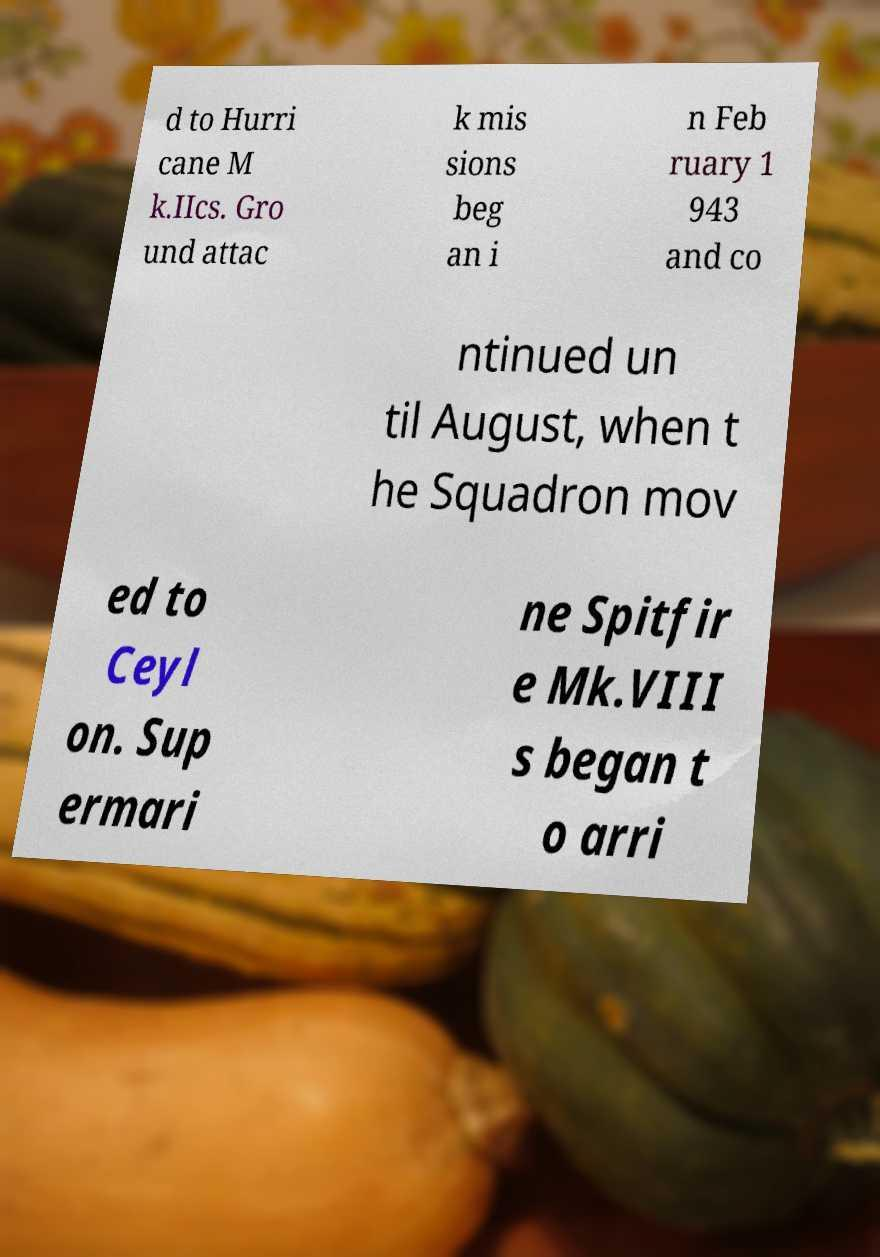Could you assist in decoding the text presented in this image and type it out clearly? d to Hurri cane M k.IIcs. Gro und attac k mis sions beg an i n Feb ruary 1 943 and co ntinued un til August, when t he Squadron mov ed to Ceyl on. Sup ermari ne Spitfir e Mk.VIII s began t o arri 